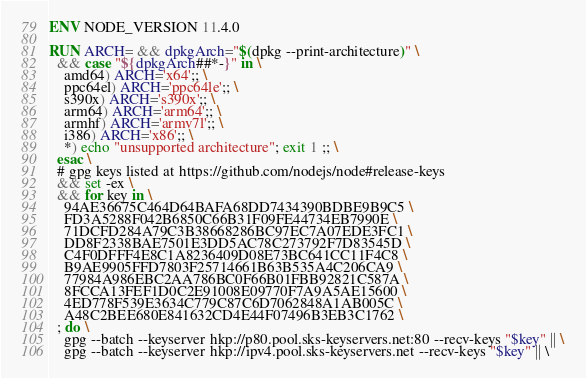Convert code to text. <code><loc_0><loc_0><loc_500><loc_500><_Dockerfile_>
ENV NODE_VERSION 11.4.0

RUN ARCH= && dpkgArch="$(dpkg --print-architecture)" \
  && case "${dpkgArch##*-}" in \
    amd64) ARCH='x64';; \
    ppc64el) ARCH='ppc64le';; \
    s390x) ARCH='s390x';; \
    arm64) ARCH='arm64';; \
    armhf) ARCH='armv7l';; \
    i386) ARCH='x86';; \
    *) echo "unsupported architecture"; exit 1 ;; \
  esac \
  # gpg keys listed at https://github.com/nodejs/node#release-keys
  && set -ex \
  && for key in \
    94AE36675C464D64BAFA68DD7434390BDBE9B9C5 \
    FD3A5288F042B6850C66B31F09FE44734EB7990E \
    71DCFD284A79C3B38668286BC97EC7A07EDE3FC1 \
    DD8F2338BAE7501E3DD5AC78C273792F7D83545D \
    C4F0DFFF4E8C1A8236409D08E73BC641CC11F4C8 \
    B9AE9905FFD7803F25714661B63B535A4C206CA9 \
    77984A986EBC2AA786BC0F66B01FBB92821C587A \
    8FCCA13FEF1D0C2E91008E09770F7A9A5AE15600 \
    4ED778F539E3634C779C87C6D7062848A1AB005C \
    A48C2BEE680E841632CD4E44F07496B3EB3C1762 \
  ; do \
    gpg --batch --keyserver hkp://p80.pool.sks-keyservers.net:80 --recv-keys "$key" || \
    gpg --batch --keyserver hkp://ipv4.pool.sks-keyservers.net --recv-keys "$key" || \</code> 